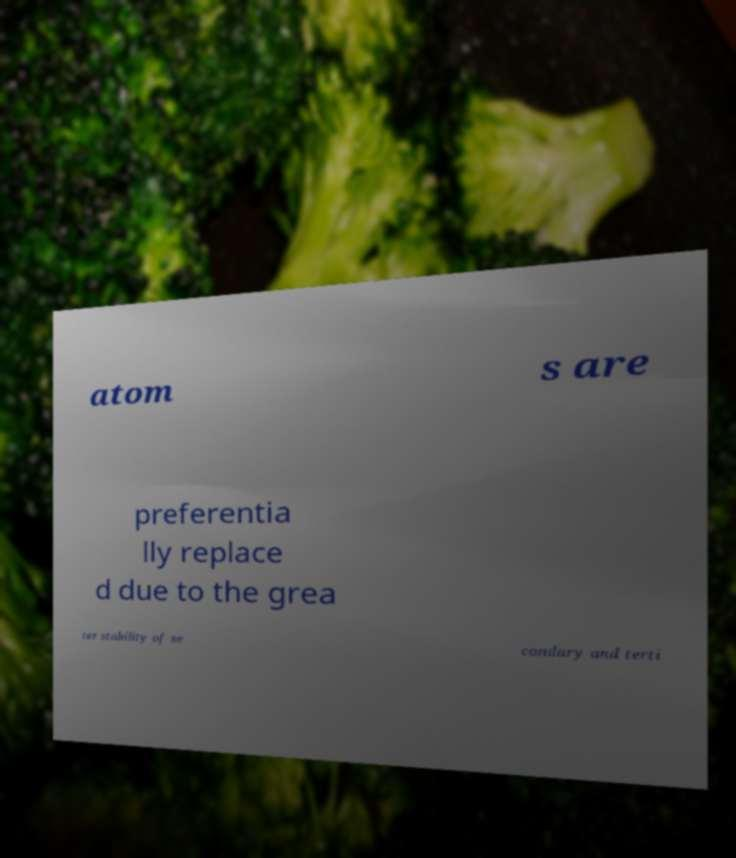Could you extract and type out the text from this image? atom s are preferentia lly replace d due to the grea ter stability of se condary and terti 